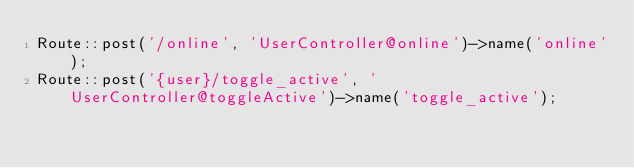<code> <loc_0><loc_0><loc_500><loc_500><_PHP_>Route::post('/online', 'UserController@online')->name('online');
Route::post('{user}/toggle_active', 'UserController@toggleActive')->name('toggle_active');
</code> 